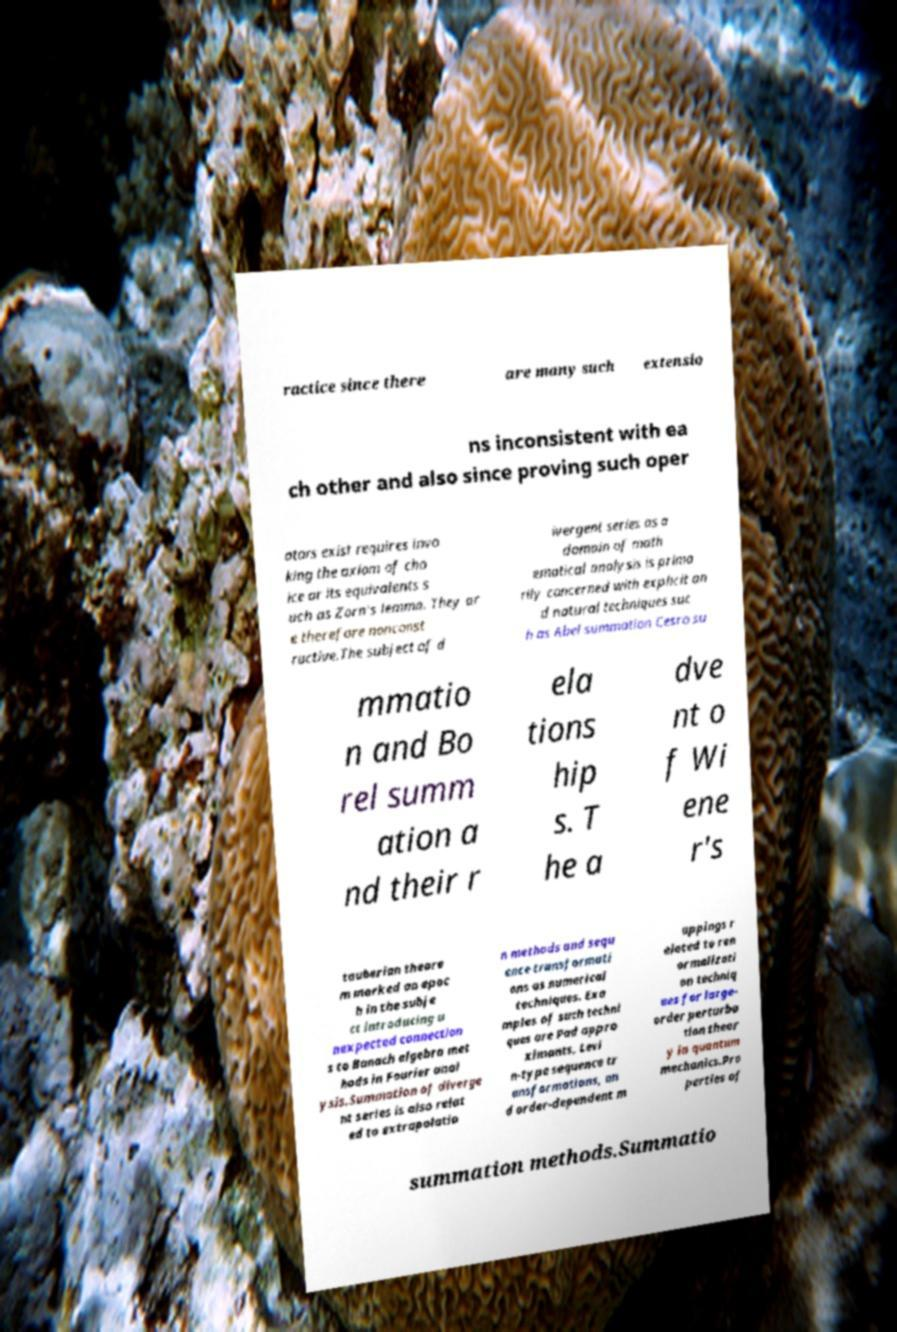Please identify and transcribe the text found in this image. ractice since there are many such extensio ns inconsistent with ea ch other and also since proving such oper ators exist requires invo king the axiom of cho ice or its equivalents s uch as Zorn's lemma. They ar e therefore nonconst ructive.The subject of d ivergent series as a domain of math ematical analysis is prima rily concerned with explicit an d natural techniques suc h as Abel summation Cesro su mmatio n and Bo rel summ ation a nd their r ela tions hip s. T he a dve nt o f Wi ene r's tauberian theore m marked an epoc h in the subje ct introducing u nexpected connection s to Banach algebra met hods in Fourier anal ysis.Summation of diverge nt series is also relat ed to extrapolatio n methods and sequ ence transformati ons as numerical techniques. Exa mples of such techni ques are Pad appro ximants, Levi n-type sequence tr ansformations, an d order-dependent m appings r elated to ren ormalizati on techniq ues for large- order perturba tion theor y in quantum mechanics.Pro perties of summation methods.Summatio 